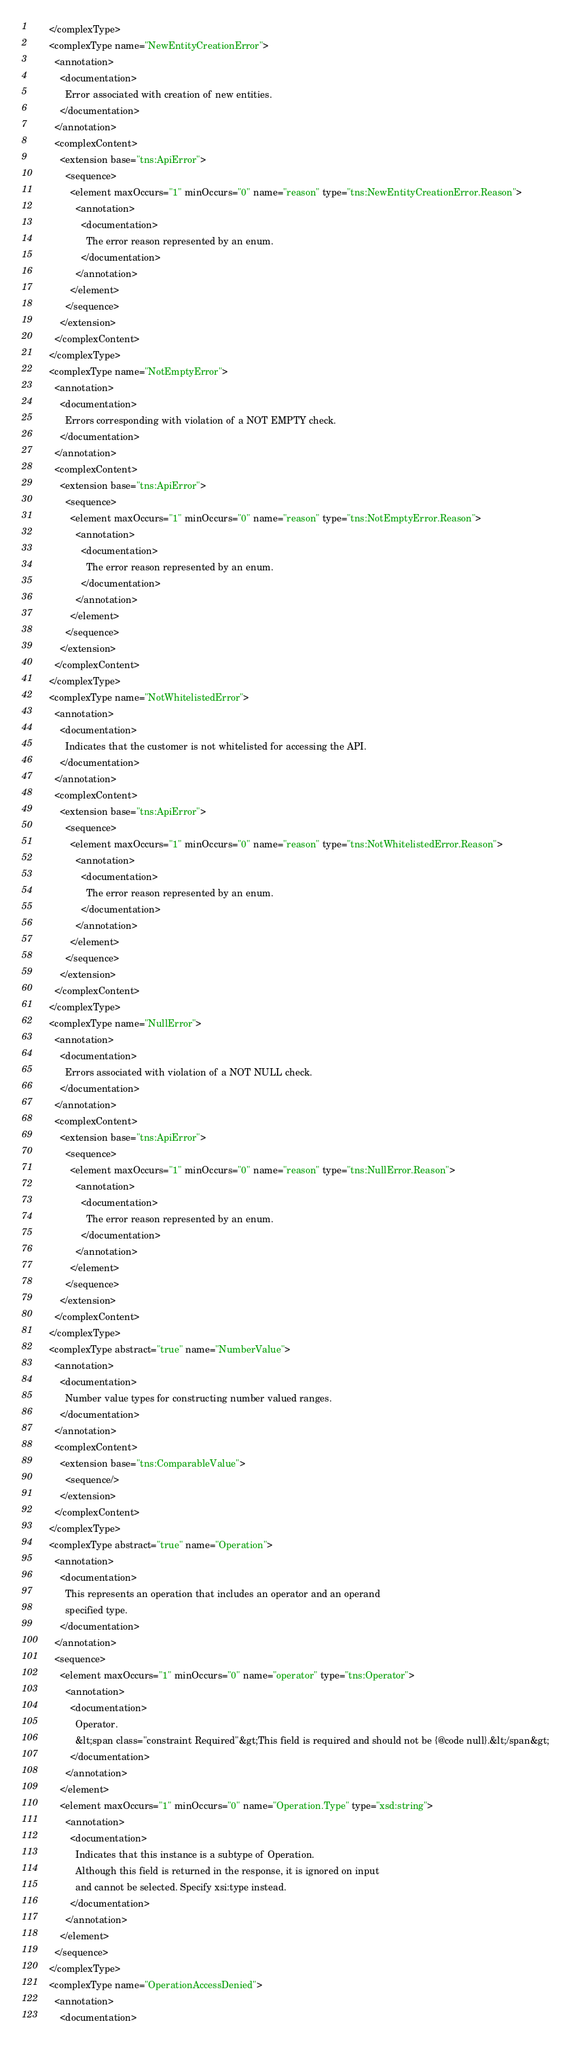<code> <loc_0><loc_0><loc_500><loc_500><_XML_>      </complexType>
      <complexType name="NewEntityCreationError">
        <annotation>
          <documentation>
            Error associated with creation of new entities.
          </documentation>
        </annotation>
        <complexContent>
          <extension base="tns:ApiError">
            <sequence>
              <element maxOccurs="1" minOccurs="0" name="reason" type="tns:NewEntityCreationError.Reason">
                <annotation>
                  <documentation>
                    The error reason represented by an enum.
                  </documentation>
                </annotation>
              </element>
            </sequence>
          </extension>
        </complexContent>
      </complexType>
      <complexType name="NotEmptyError">
        <annotation>
          <documentation>
            Errors corresponding with violation of a NOT EMPTY check.
          </documentation>
        </annotation>
        <complexContent>
          <extension base="tns:ApiError">
            <sequence>
              <element maxOccurs="1" minOccurs="0" name="reason" type="tns:NotEmptyError.Reason">
                <annotation>
                  <documentation>
                    The error reason represented by an enum.
                  </documentation>
                </annotation>
              </element>
            </sequence>
          </extension>
        </complexContent>
      </complexType>
      <complexType name="NotWhitelistedError">
        <annotation>
          <documentation>
            Indicates that the customer is not whitelisted for accessing the API.
          </documentation>
        </annotation>
        <complexContent>
          <extension base="tns:ApiError">
            <sequence>
              <element maxOccurs="1" minOccurs="0" name="reason" type="tns:NotWhitelistedError.Reason">
                <annotation>
                  <documentation>
                    The error reason represented by an enum.
                  </documentation>
                </annotation>
              </element>
            </sequence>
          </extension>
        </complexContent>
      </complexType>
      <complexType name="NullError">
        <annotation>
          <documentation>
            Errors associated with violation of a NOT NULL check.
          </documentation>
        </annotation>
        <complexContent>
          <extension base="tns:ApiError">
            <sequence>
              <element maxOccurs="1" minOccurs="0" name="reason" type="tns:NullError.Reason">
                <annotation>
                  <documentation>
                    The error reason represented by an enum.
                  </documentation>
                </annotation>
              </element>
            </sequence>
          </extension>
        </complexContent>
      </complexType>
      <complexType abstract="true" name="NumberValue">
        <annotation>
          <documentation>
            Number value types for constructing number valued ranges.
          </documentation>
        </annotation>
        <complexContent>
          <extension base="tns:ComparableValue">
            <sequence/>
          </extension>
        </complexContent>
      </complexType>
      <complexType abstract="true" name="Operation">
        <annotation>
          <documentation>
            This represents an operation that includes an operator and an operand
            specified type.
          </documentation>
        </annotation>
        <sequence>
          <element maxOccurs="1" minOccurs="0" name="operator" type="tns:Operator">
            <annotation>
              <documentation>
                Operator.
                &lt;span class="constraint Required"&gt;This field is required and should not be {@code null}.&lt;/span&gt;
              </documentation>
            </annotation>
          </element>
          <element maxOccurs="1" minOccurs="0" name="Operation.Type" type="xsd:string">
            <annotation>
              <documentation>
                Indicates that this instance is a subtype of Operation.
                Although this field is returned in the response, it is ignored on input
                and cannot be selected. Specify xsi:type instead.
              </documentation>
            </annotation>
          </element>
        </sequence>
      </complexType>
      <complexType name="OperationAccessDenied">
        <annotation>
          <documentation></code> 